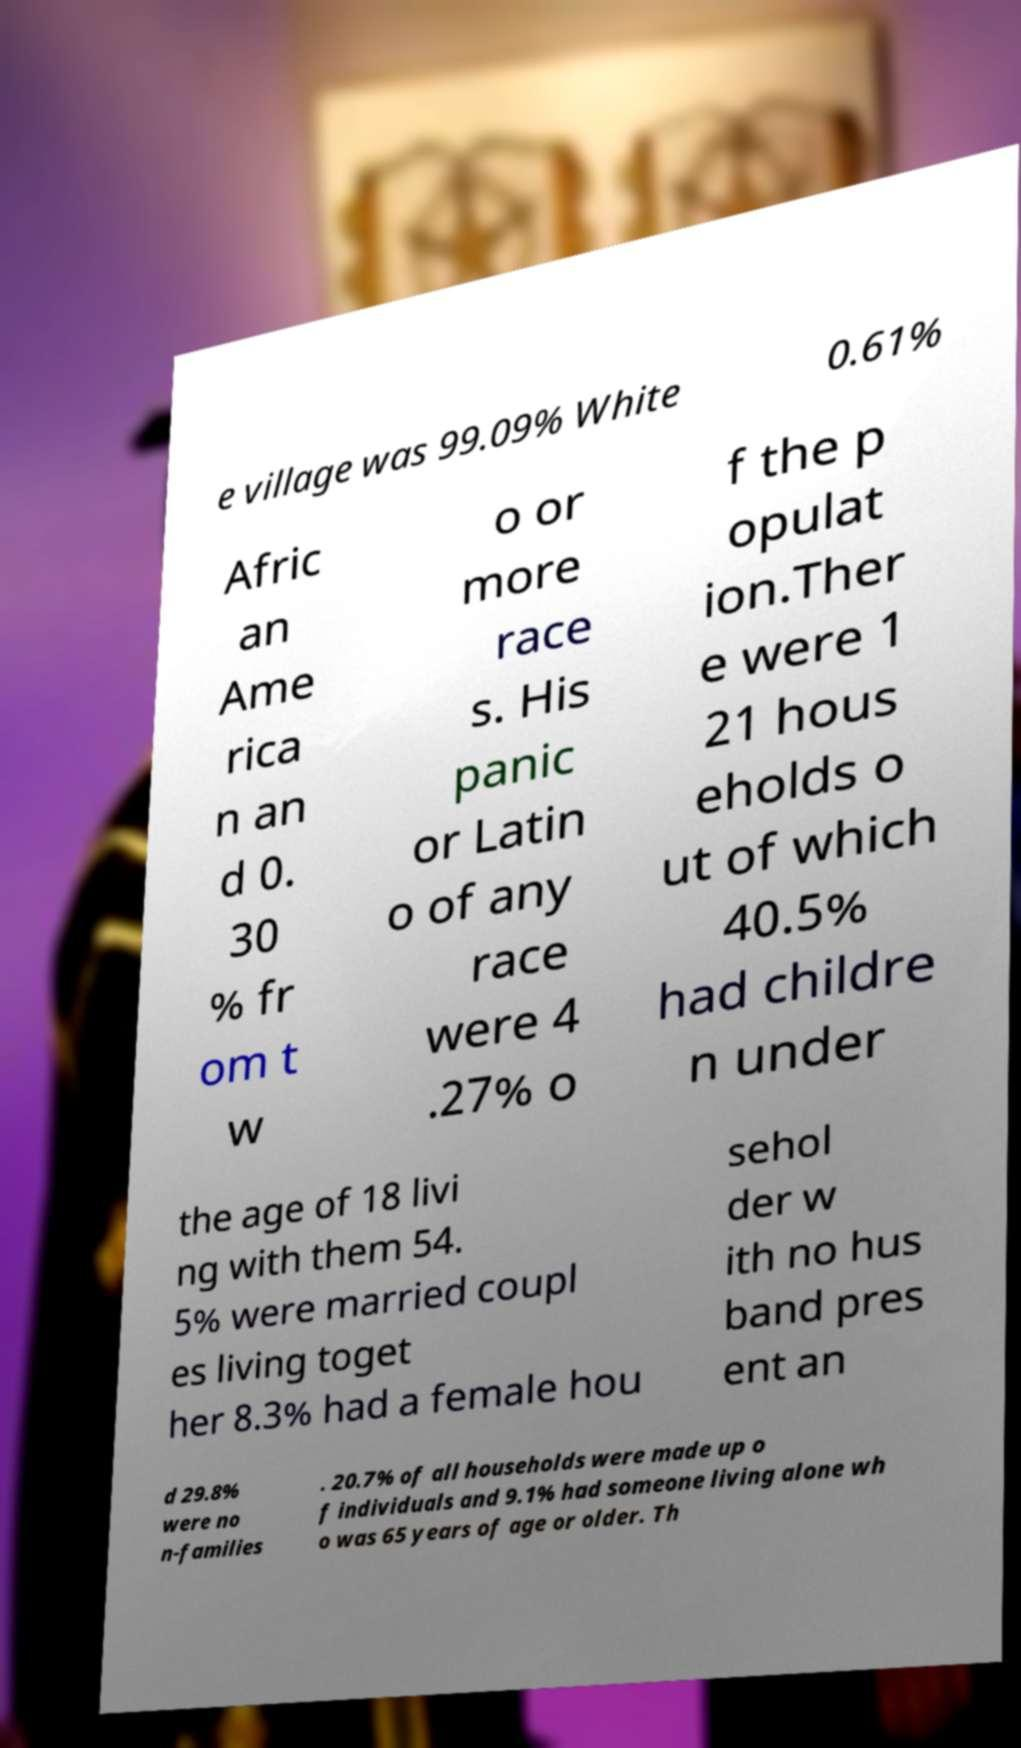Can you read and provide the text displayed in the image?This photo seems to have some interesting text. Can you extract and type it out for me? e village was 99.09% White 0.61% Afric an Ame rica n an d 0. 30 % fr om t w o or more race s. His panic or Latin o of any race were 4 .27% o f the p opulat ion.Ther e were 1 21 hous eholds o ut of which 40.5% had childre n under the age of 18 livi ng with them 54. 5% were married coupl es living toget her 8.3% had a female hou sehol der w ith no hus band pres ent an d 29.8% were no n-families . 20.7% of all households were made up o f individuals and 9.1% had someone living alone wh o was 65 years of age or older. Th 